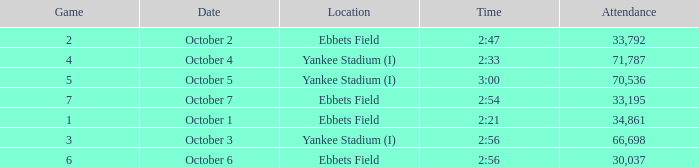The game of 6 has what lowest attendance? 30037.0. 